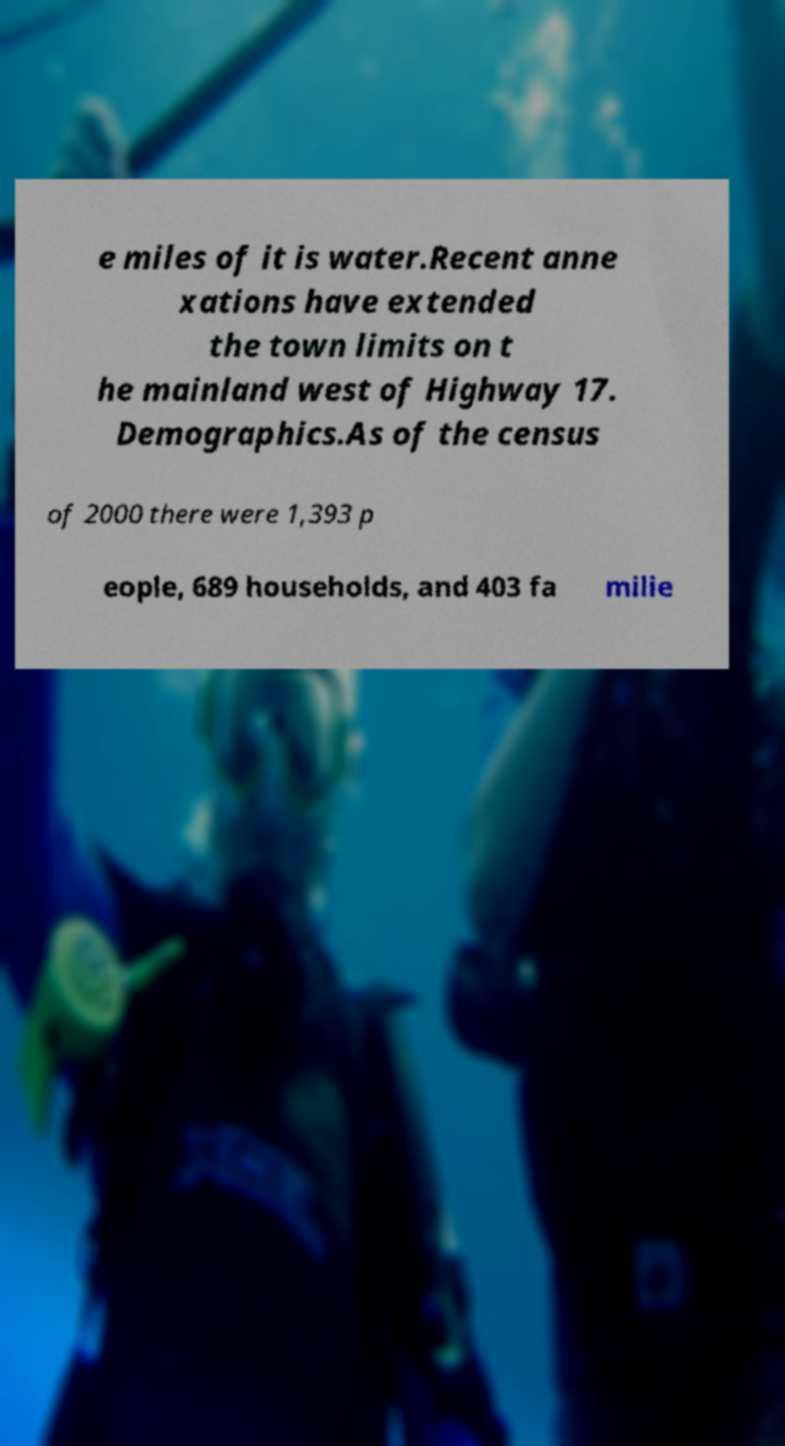Please read and relay the text visible in this image. What does it say? e miles of it is water.Recent anne xations have extended the town limits on t he mainland west of Highway 17. Demographics.As of the census of 2000 there were 1,393 p eople, 689 households, and 403 fa milie 